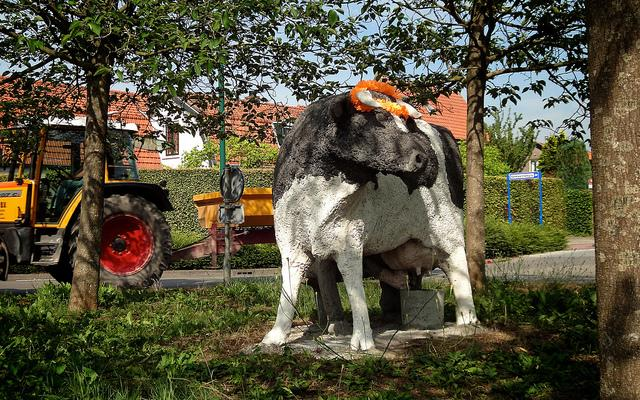What feature of the animal is visible? Please explain your reasoning. udder. The animal is a cow, not a fish, bird, or bee. 